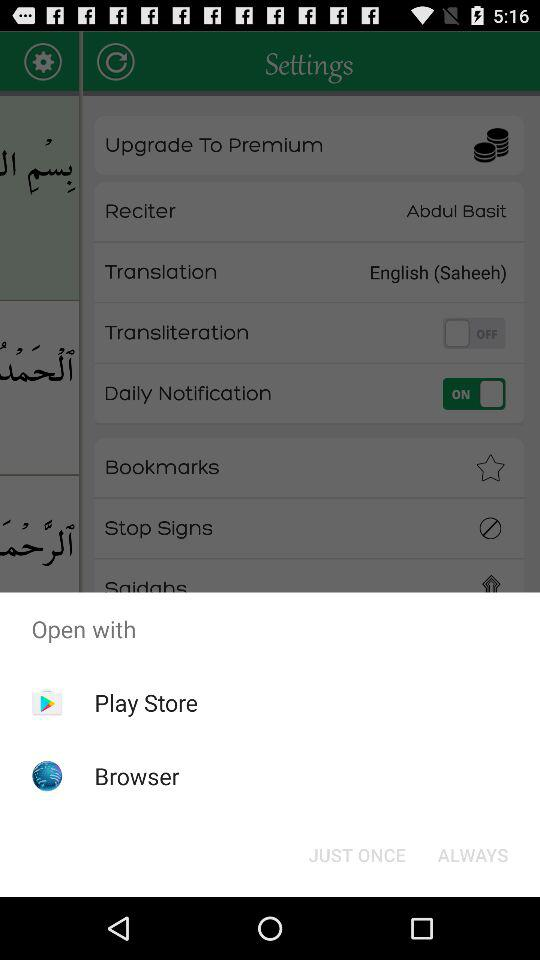What applications can be used to open it? The applications that can be used to open it are : "Play Store" and "Browser". 